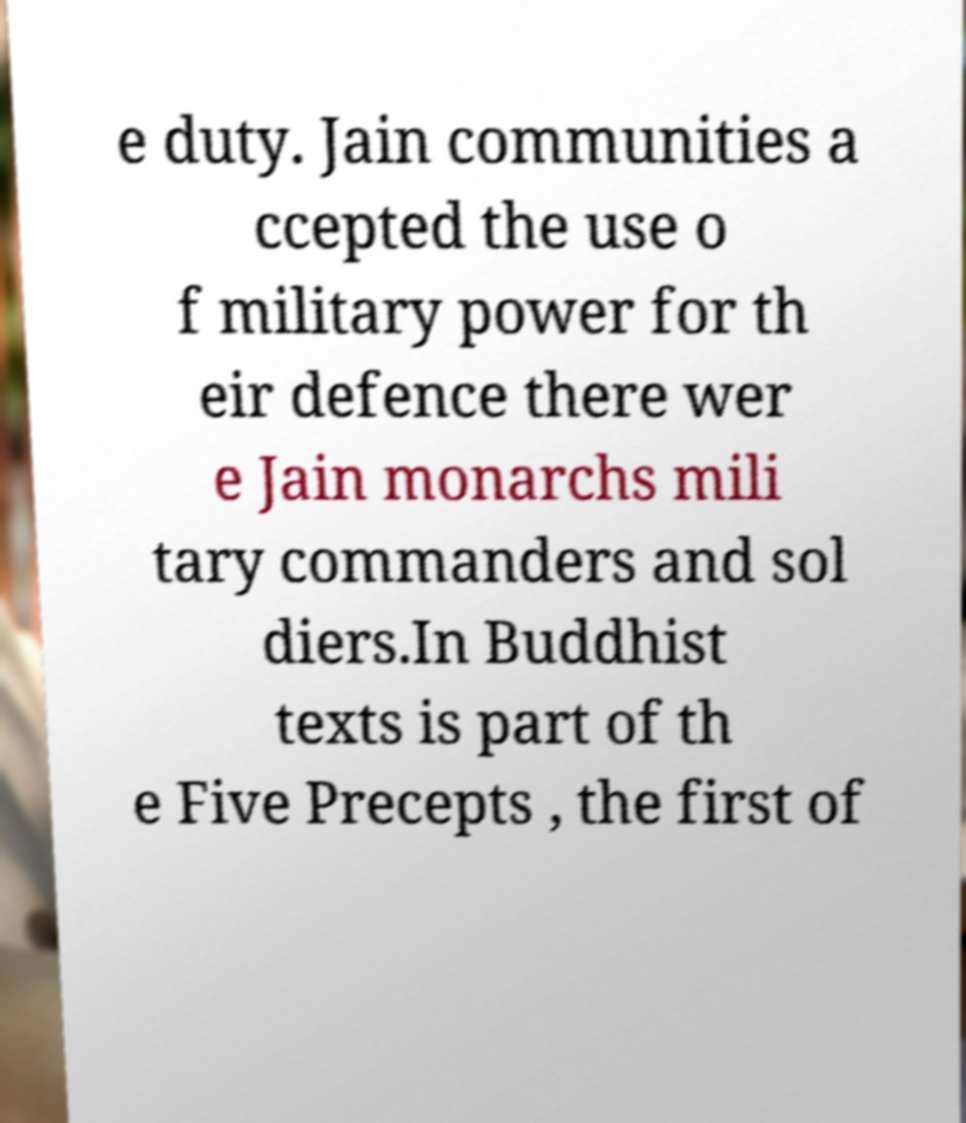Can you accurately transcribe the text from the provided image for me? e duty. Jain communities a ccepted the use o f military power for th eir defence there wer e Jain monarchs mili tary commanders and sol diers.In Buddhist texts is part of th e Five Precepts , the first of 